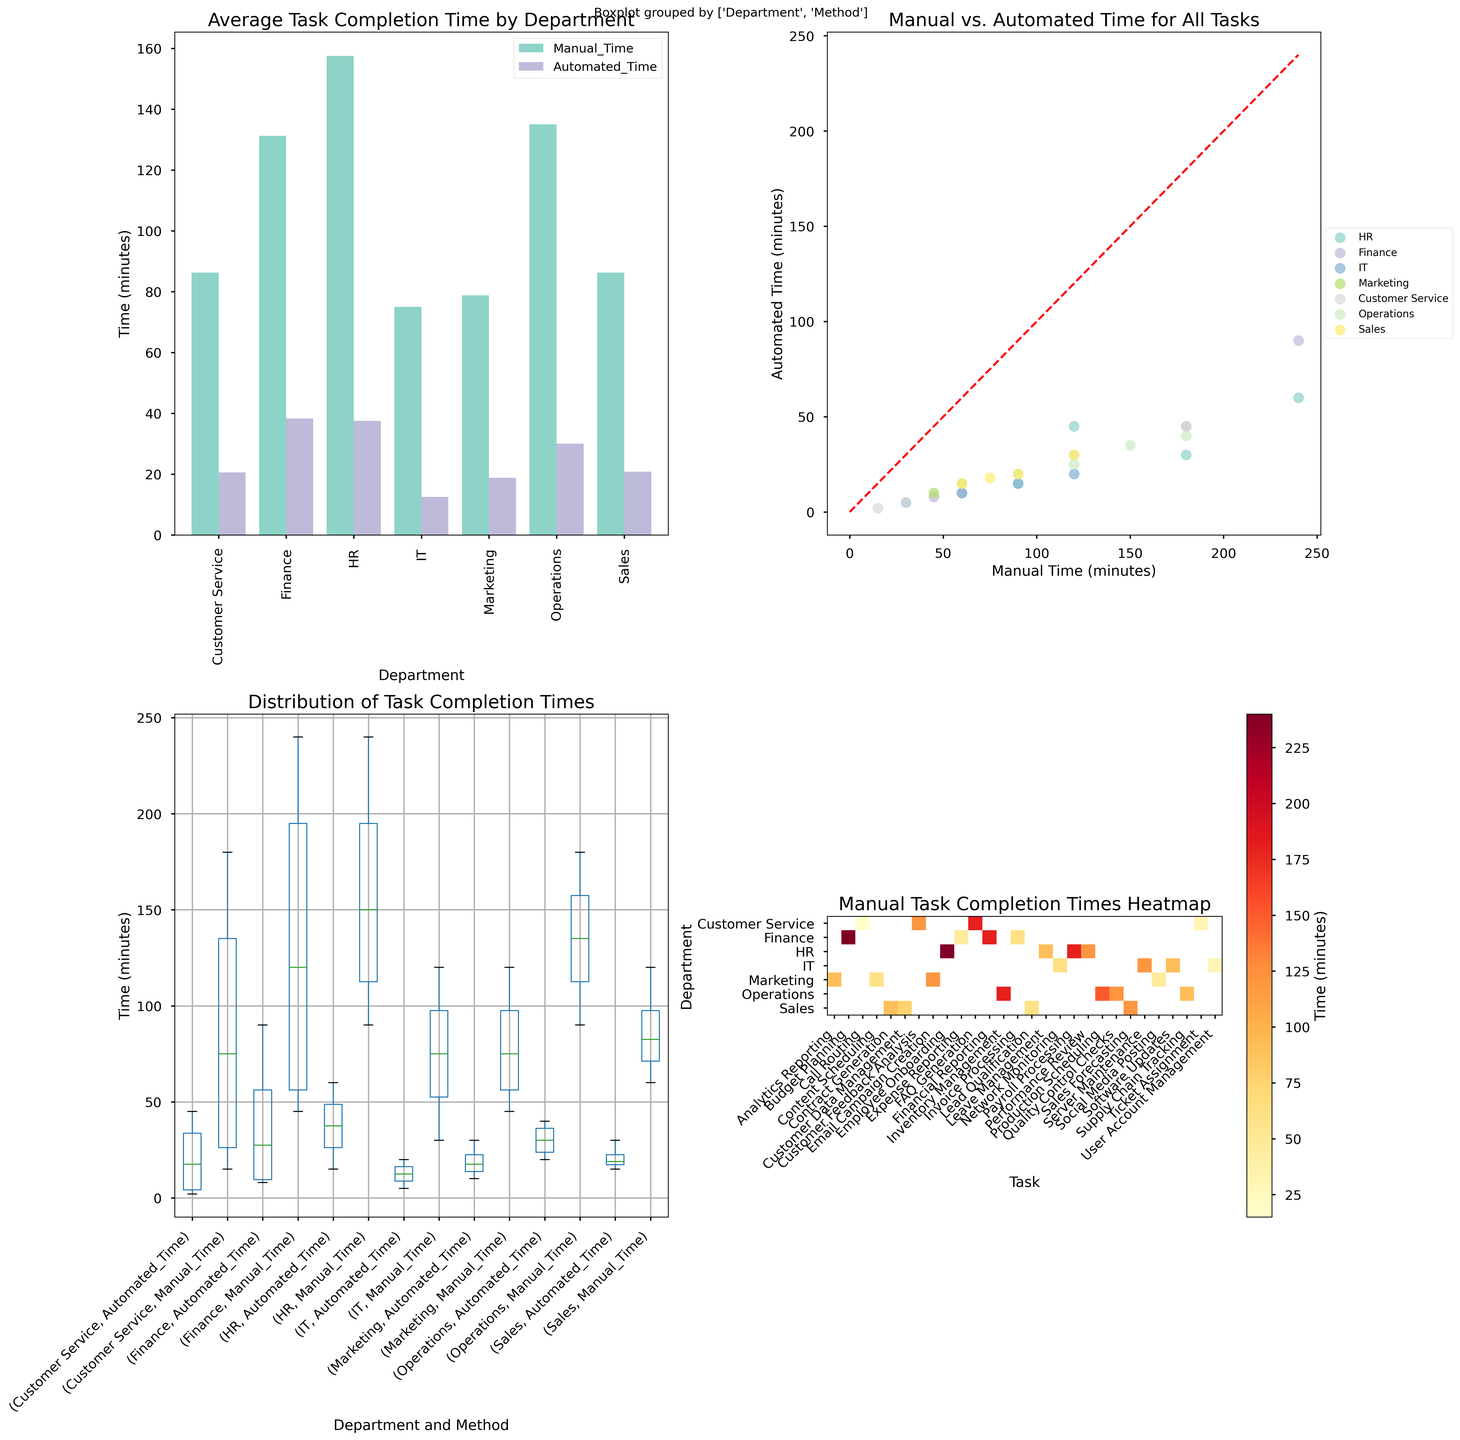How much manual time is saved on average by automation in the HR department? First, find the average manual and automated times for HR from the bar plot. Calculate the difference between these averages.
HR (Manual Time) = (240 + 180 + 120 + 90) / 4 = 157.5 minutes.
HR (Automated Time) = (60 + 30 + 45 + 15) / 4 = 37.5 minutes.
Time saved = 157.5 - 37.5 = 120 minutes.
Answer: 120 minutes Which department shows the greatest reduction in task completion time from manual to automated methods? Look at the bar plot for the department with the highest difference between manual and automated times. From the bar plot, compare the heights of the bars for manual and automated times to find the largest gap.
Finance: 110 minutes.
Answer: Finance Comparing manual task times, which department has the highest overall manual task completion time? Refer to the heatmap of manual task completion times. The department with the highest values when summed up will be the answer. 
Sum up the cells of each row.
Finance: 60+45+180+240 = 525 minutes.
Answer: Finance When considering all tasks, which department's automated task completion time shows the least variability? Check the box plot for the closeness of the whiskers and boxes related to 'Automated Time' for each department. The department with the shortest box and whisker range indicates the least variability.
Operations' boxplot for automated times is the most compact, indicating the least variability.
Answer: Operations Identify a task where the automated completion time is consistently low across all departments? Look at the scatter plot for tasks where automation time forms a cluster near the origin (low times). From the scatter plot, identify which tasks appear in the very low timeframe.
Tasks like "Leave Management," "Ticket Assignment," and "Call Routing" are consistently low in automated times.
Answer: Leave Management What is the median manual task completion time in the Finance department? Refer to the box plot under the 'Manual_Time' category for the Finance department. Identify the median using the center line of the box plot.
By looking at the box plot, the median line for Finance falls around 120 minutes.
Answer: 120 minutes In the scatter plot, which department has the most tightly grouped data points, indicating low variability between manual and automated times for its tasks? In the scatter plot, look closely for the department whose points form a compact group with minimal spread.
Operations' tasks are tightly grouped, showing low variability.
Answer: Operations From the heatmap, which department has the widest range of manual task completion times? Check the heatmap for the department with the variance from the lowest to the highest value in its row.
Finance: ranges from 45 to 240 minutes.
Answer: Finance Based on the average task completion times, which department can benefit the most from automation? Why? From the bar plot of average times, calculate which department saves the most time on average by automation (difference between manual and automated times).
Finance reduces from an average manual time of 131.25 minutes to 38.75 minutes, a reduction of 92.5 minutes. This substantial gain suggests the most significant benefit.
Finance, with an avg. manual time reducing from 131.25 to 38.75, saving 92.5 mins on avg.
Answer: Finance Which department has the least difference between manual and automated task completion times? On the bar plot, examine which department has the smallest gap between the manual and automated bars.
IT: 60 (manual) - 12.5 (automated) = 47.5 minutes.
Answer: IT 